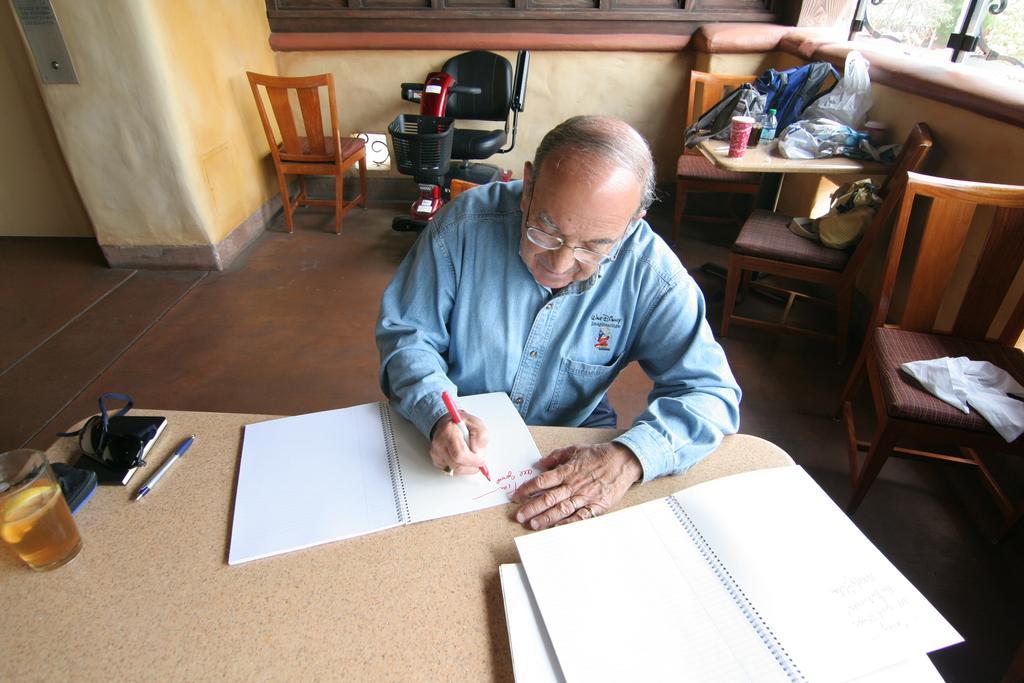How would you summarize this image in a sentence or two? In this image we can see a person wearing blue color shirt sitting on a chair writing something in book and there are some books, glass, pen and some other items on table and in the background of the image there are some chairs, table on which there are some objects and there is a wall. 